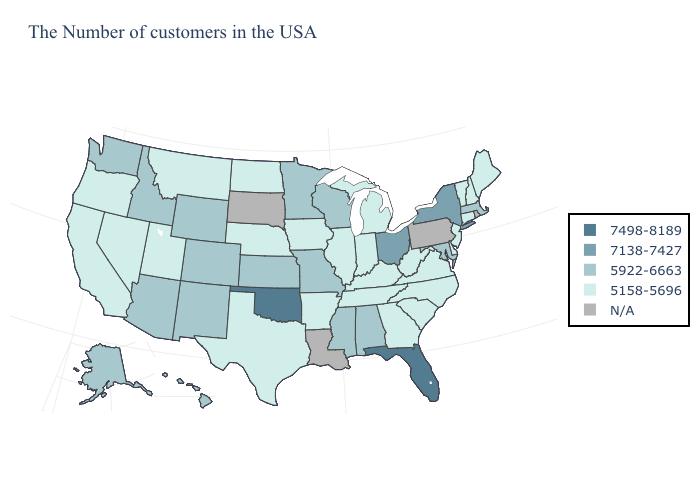Name the states that have a value in the range 5922-6663?
Be succinct. Massachusetts, Maryland, Alabama, Wisconsin, Mississippi, Missouri, Minnesota, Kansas, Wyoming, Colorado, New Mexico, Arizona, Idaho, Washington, Alaska, Hawaii. What is the value of Iowa?
Be succinct. 5158-5696. Which states hav the highest value in the South?
Concise answer only. Florida, Oklahoma. Among the states that border Indiana , does Ohio have the lowest value?
Keep it brief. No. What is the highest value in the West ?
Quick response, please. 5922-6663. What is the lowest value in the MidWest?
Keep it brief. 5158-5696. Does the first symbol in the legend represent the smallest category?
Answer briefly. No. What is the lowest value in states that border Kansas?
Quick response, please. 5158-5696. Among the states that border Maine , which have the highest value?
Quick response, please. New Hampshire. What is the value of Arizona?
Concise answer only. 5922-6663. Does the first symbol in the legend represent the smallest category?
Write a very short answer. No. Does New York have the highest value in the USA?
Short answer required. No. Which states hav the highest value in the South?
Give a very brief answer. Florida, Oklahoma. Name the states that have a value in the range 7498-8189?
Write a very short answer. Florida, Oklahoma. What is the lowest value in the Northeast?
Write a very short answer. 5158-5696. 